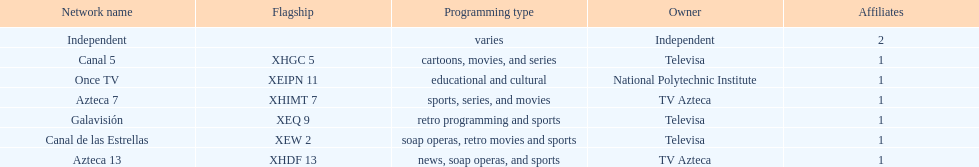What is the only network owned by national polytechnic institute? Once TV. 